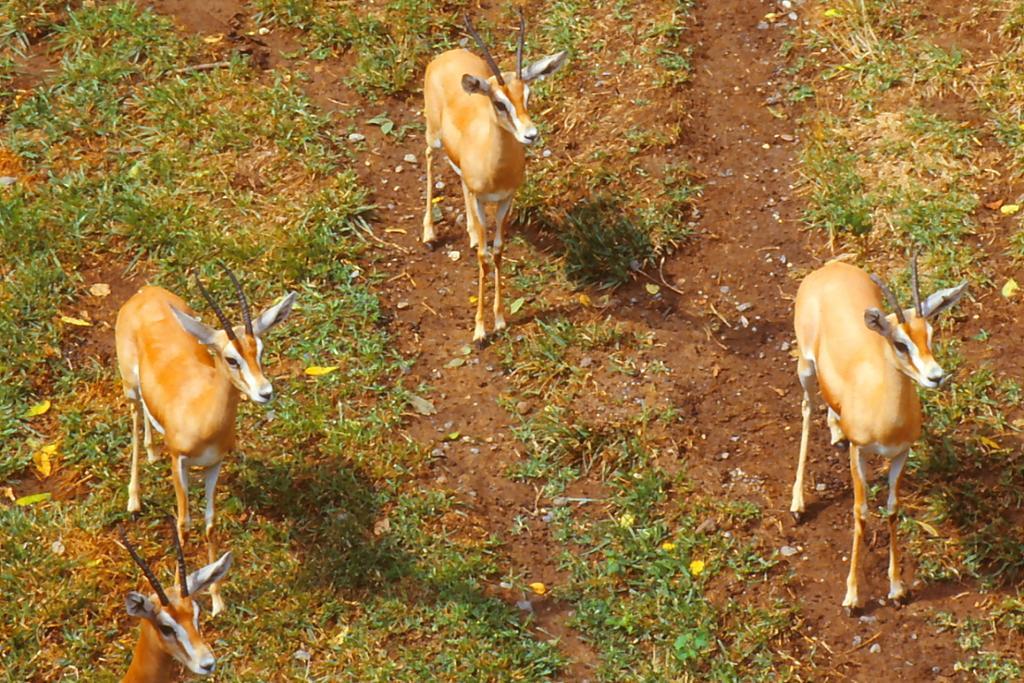Describe this image in one or two sentences. In this image we can see a herd on the ground. We can also see some grass. 